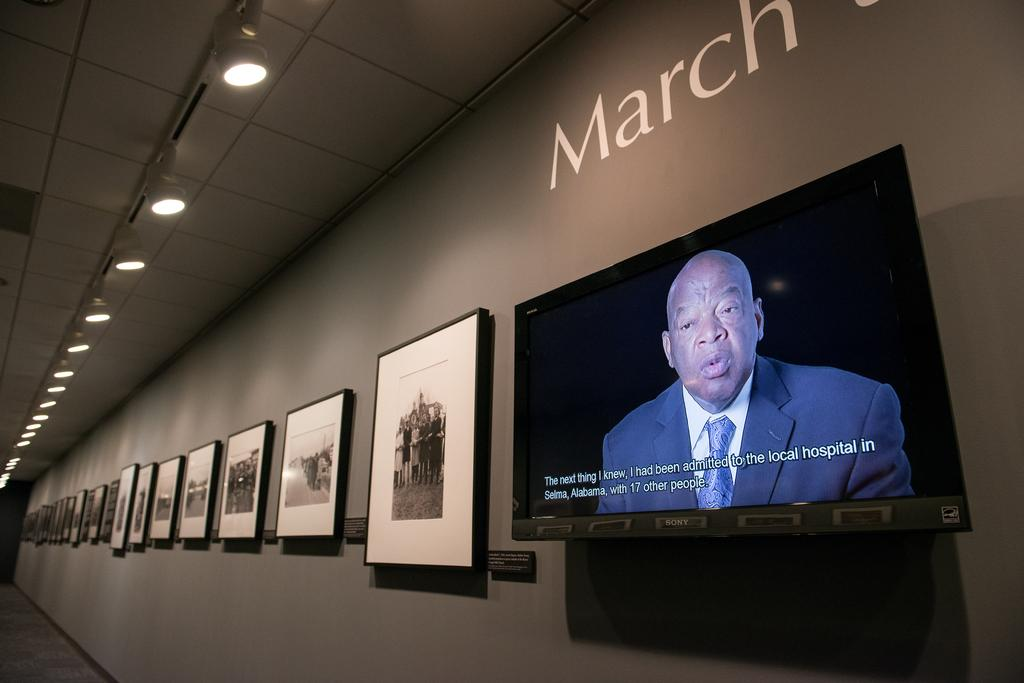What objects are present in the image that have a frame? There are frames in the image. Where is the television located in the image? The television is attached to the wall in the image. What type of illumination can be seen in the image? There are lights visible in the image. What type of pancake is being cooked on the cannon in the image? There is no pancake or cannon present in the image. What type of cloud is visible in the image? There is no cloud visible in the image. 